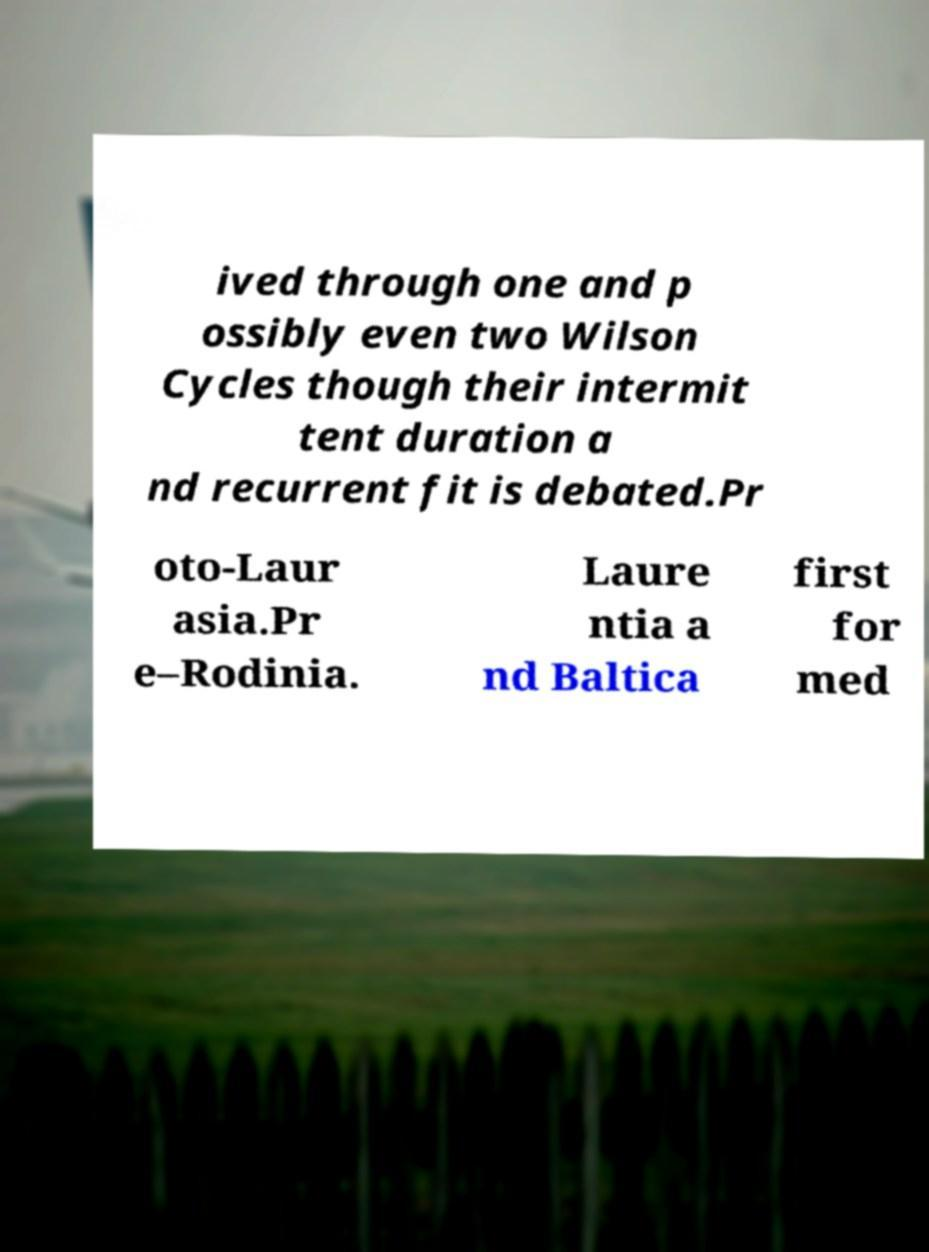Can you read and provide the text displayed in the image?This photo seems to have some interesting text. Can you extract and type it out for me? ived through one and p ossibly even two Wilson Cycles though their intermit tent duration a nd recurrent fit is debated.Pr oto-Laur asia.Pr e–Rodinia. Laure ntia a nd Baltica first for med 